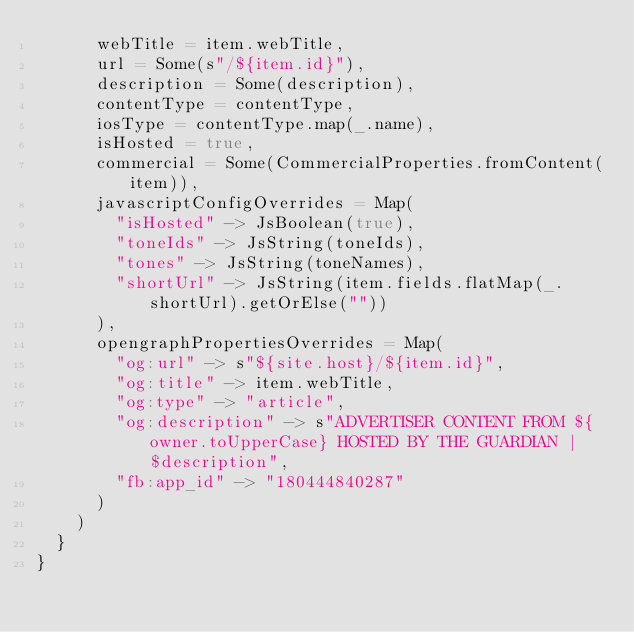<code> <loc_0><loc_0><loc_500><loc_500><_Scala_>      webTitle = item.webTitle,
      url = Some(s"/${item.id}"),
      description = Some(description),
      contentType = contentType,
      iosType = contentType.map(_.name),
      isHosted = true,
      commercial = Some(CommercialProperties.fromContent(item)),
      javascriptConfigOverrides = Map(
        "isHosted" -> JsBoolean(true),
        "toneIds" -> JsString(toneIds),
        "tones" -> JsString(toneNames),
        "shortUrl" -> JsString(item.fields.flatMap(_.shortUrl).getOrElse(""))
      ),
      opengraphPropertiesOverrides = Map(
        "og:url" -> s"${site.host}/${item.id}",
        "og:title" -> item.webTitle,
        "og:type" -> "article",
        "og:description" -> s"ADVERTISER CONTENT FROM ${owner.toUpperCase} HOSTED BY THE GUARDIAN | $description",
        "fb:app_id" -> "180444840287"
      )
    )
  }
}
</code> 